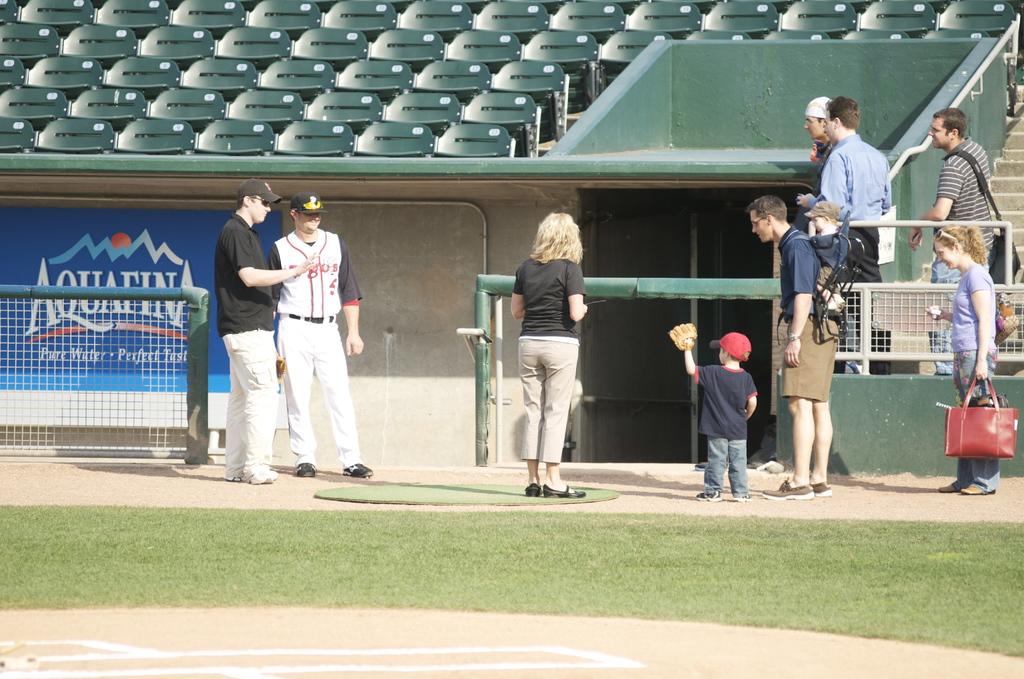What brand of water has a sponsorship at this stadium?
Offer a terse response. Aquafina. How is the water taste described?
Your response must be concise. Perfect. 